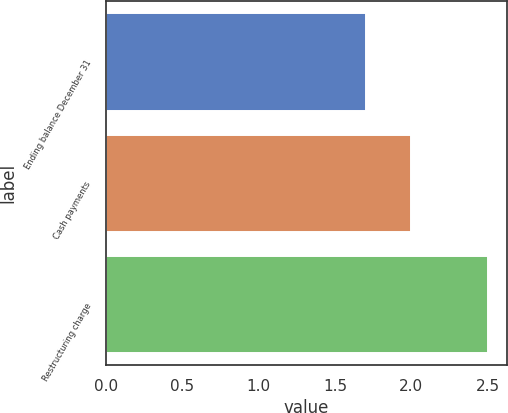<chart> <loc_0><loc_0><loc_500><loc_500><bar_chart><fcel>Ending balance December 31<fcel>Cash payments<fcel>Restructuring charge<nl><fcel>1.7<fcel>2<fcel>2.5<nl></chart> 